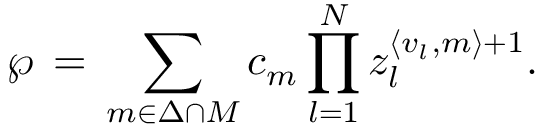<formula> <loc_0><loc_0><loc_500><loc_500>\wp \, = \, \sum _ { { m } \in { \Delta \cap M } } c _ { m } \prod _ { l = 1 } ^ { N } z _ { l } ^ { \langle { v } _ { l } , { m } \rangle + 1 } .</formula> 